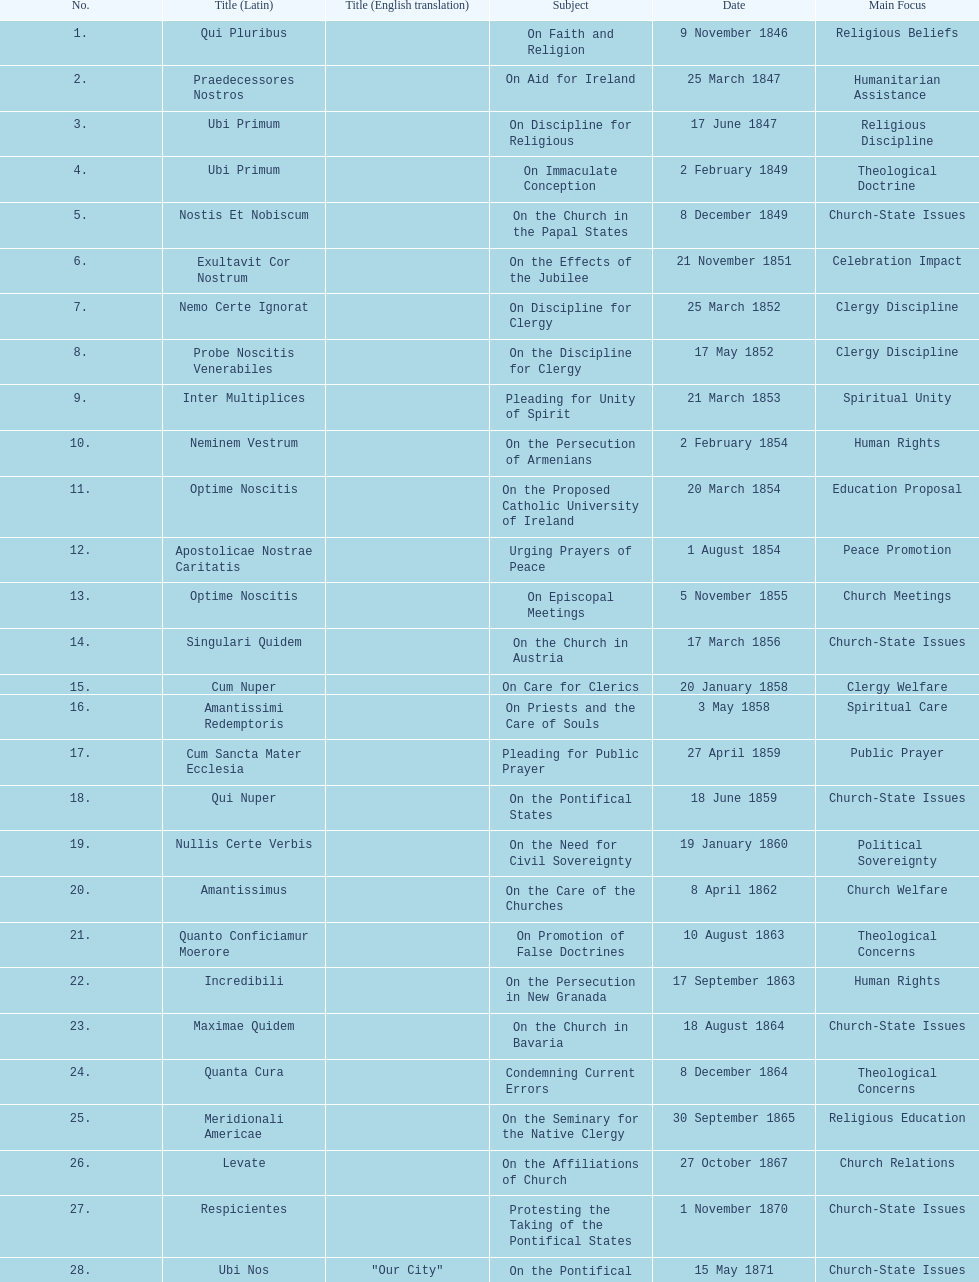How often was an encyclical sent in january? 3. 